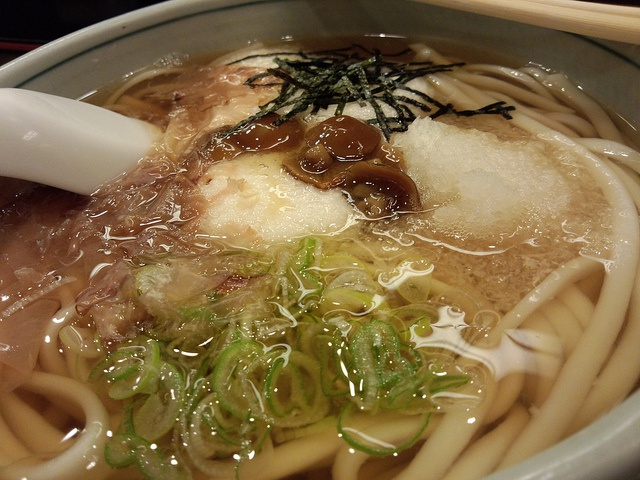Describe the objects in this image and their specific colors. I can see bowl in olive, tan, and maroon tones and spoon in black, darkgray, gray, tan, and lightgray tones in this image. 